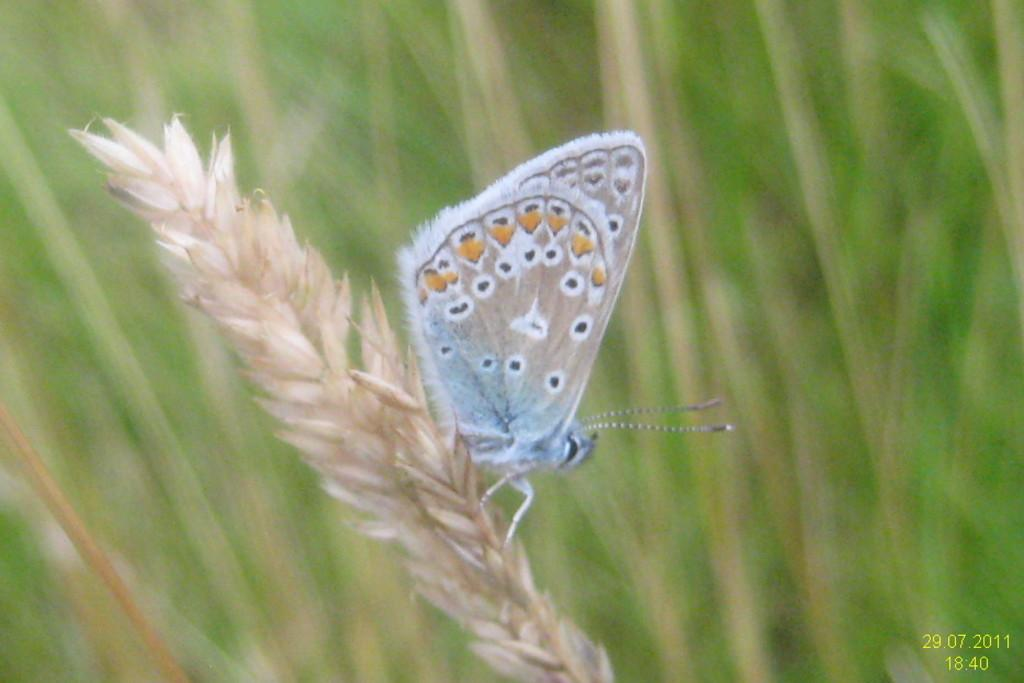What is the main subject of the image? The main subject of the image is a stem with rice grains. Is there any living organism present in the image? Yes, there is a butterfly on the stem. What color is the background of the image? The background of the image is green. Is there any additional information displayed in the image? Yes, there is a time and date displayed in the right bottom of the image. How many pizzas can be seen floating on the water in the image? There are no pizzas or water present in the image; it features a stem with rice grains and a butterfly. What type of flag is visible on the boat in the image? There is no boat or flag present in the image. 